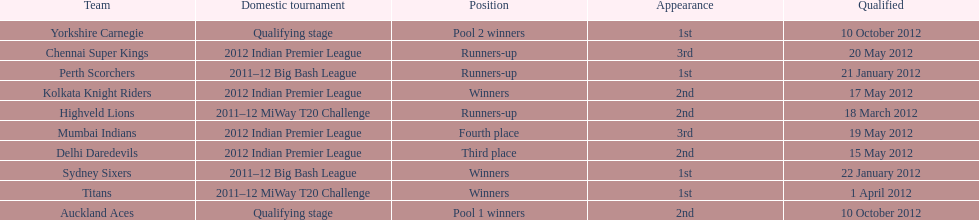The auckland aces and yorkshire carnegie qualified on what date? 10 October 2012. 